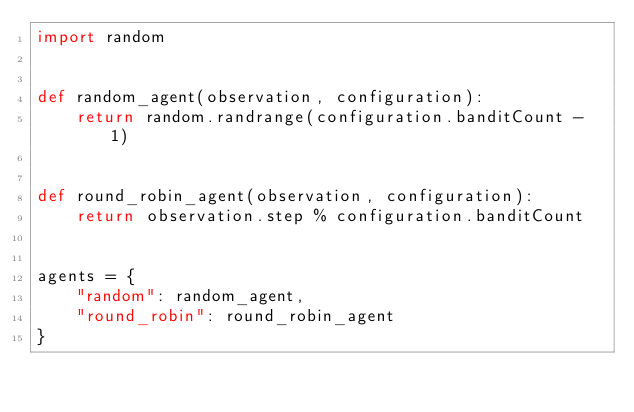<code> <loc_0><loc_0><loc_500><loc_500><_Python_>import random


def random_agent(observation, configuration):
    return random.randrange(configuration.banditCount - 1)


def round_robin_agent(observation, configuration):
    return observation.step % configuration.banditCount


agents = {
    "random": random_agent,
    "round_robin": round_robin_agent
}</code> 